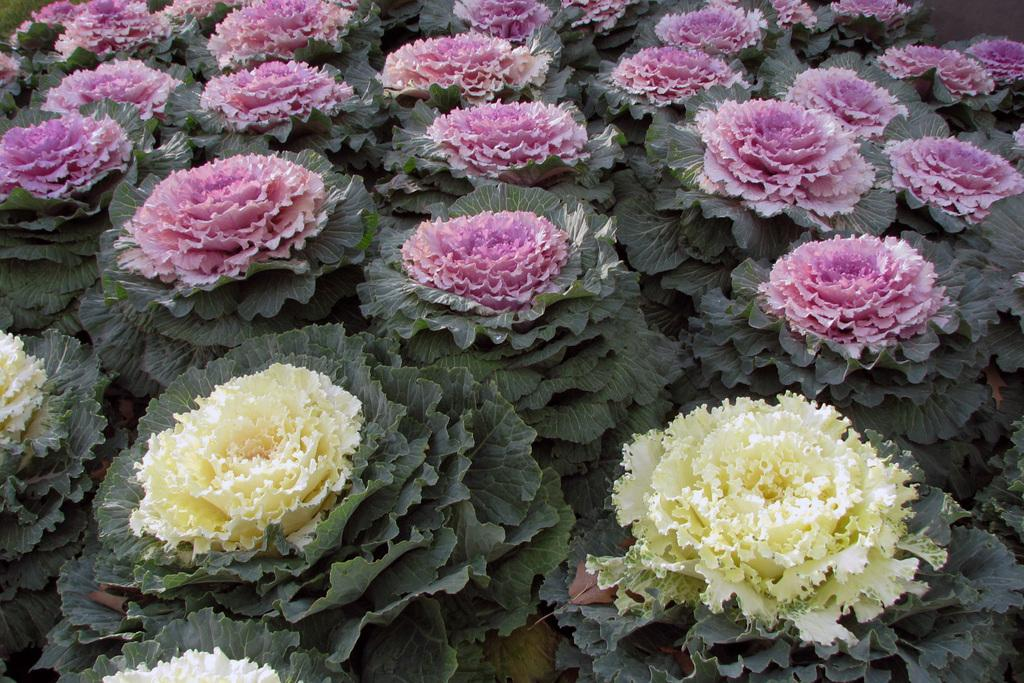What type of plants are present in the image? There are yellow and purple flower plants in the image. Can you describe the location of the yellow flower plants? The yellow flower plants are at the bottom of the image. Where are the purple flower plants located in the image? The purple flower plants are at the top of the image. What type of crime is being committed in the image? There is no crime present in the image; it features flower plants. Who needs to approve the title of the image? The image does not have a title, so there is no need for approval. 